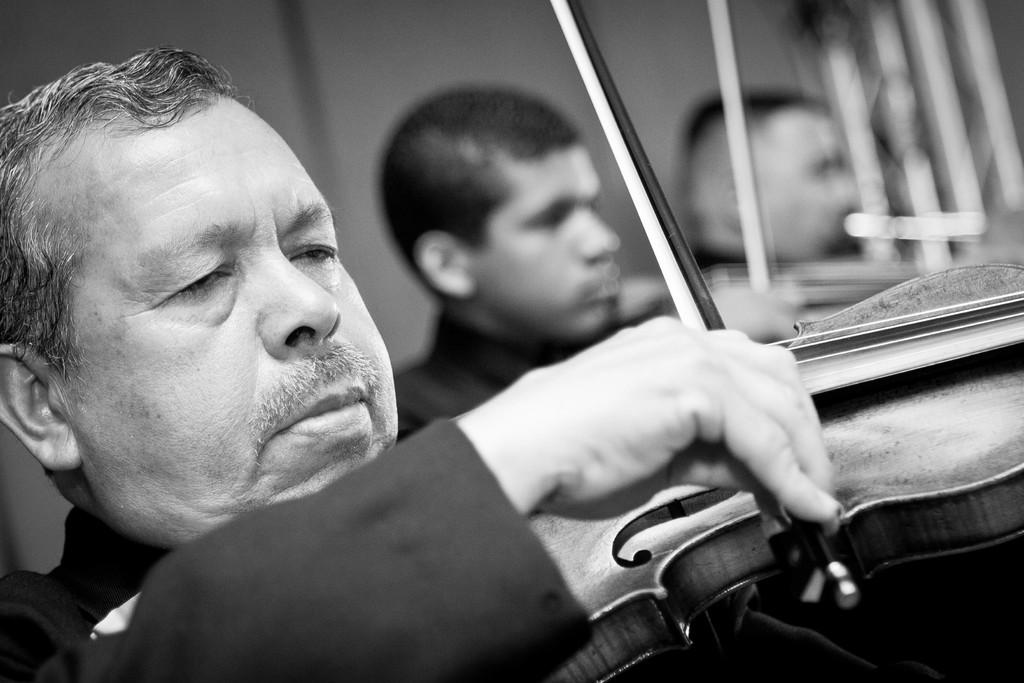What is the color scheme of the image? The image is black and white. How many people are in the image? There are three persons in the image. What are the people doing in the image? The persons are playing music instruments. What color is the background behind the people? There is a blue background behind the people. Can you see any clock with a fang in the image? No, there is no clock or fang present in the image. 